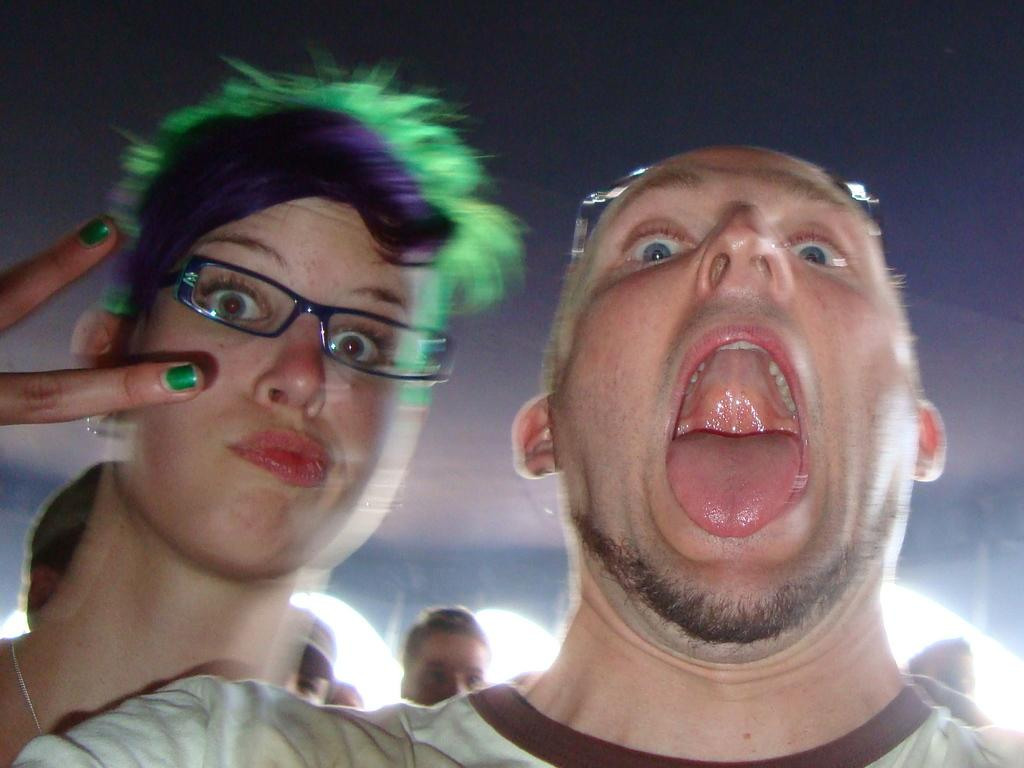What is the man doing on the right side of the image? The man appears to be shouting in the image. What is the woman doing on the left side of the image? The woman is giving a pose for the picture. Can you describe the people visible in the background of the image? There are more people visible in the background of the image, but their actions are not clear from the provided facts. What time of day is it in the image, based on the grass's height? There is no grass visible in the image, so it is not possible to determine the time of day based on its height. 